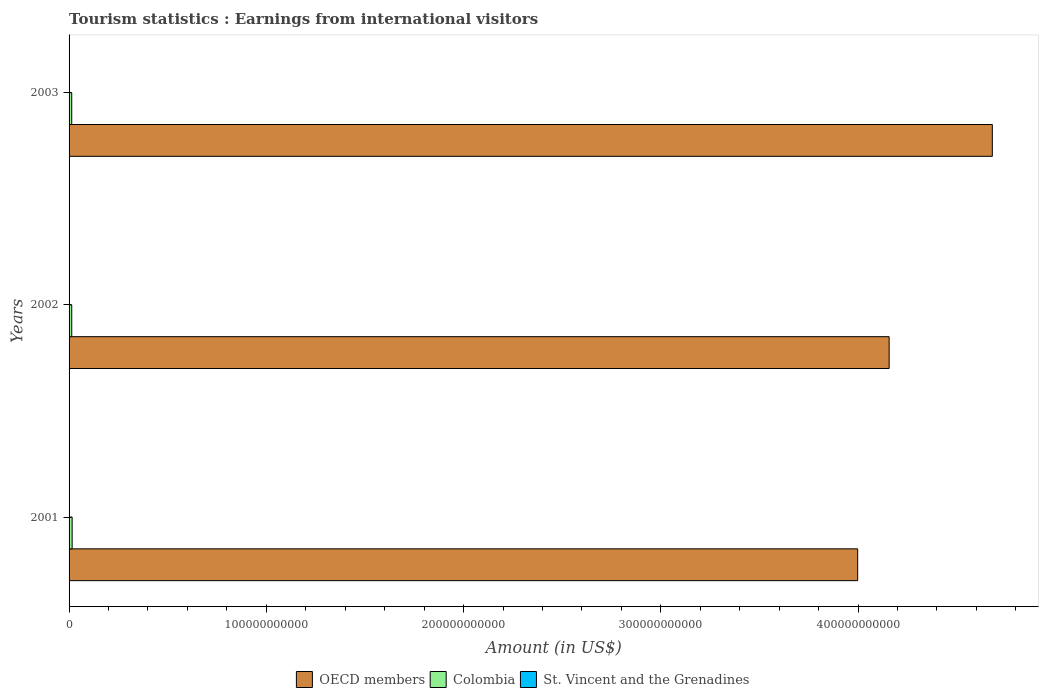How many different coloured bars are there?
Your response must be concise. 3. How many groups of bars are there?
Make the answer very short. 3. Are the number of bars on each tick of the Y-axis equal?
Your response must be concise. Yes. How many bars are there on the 1st tick from the top?
Provide a succinct answer. 3. How many bars are there on the 3rd tick from the bottom?
Make the answer very short. 3. What is the label of the 1st group of bars from the top?
Provide a succinct answer. 2003. What is the earnings from international visitors in OECD members in 2003?
Offer a terse response. 4.68e+11. Across all years, what is the maximum earnings from international visitors in OECD members?
Make the answer very short. 4.68e+11. Across all years, what is the minimum earnings from international visitors in Colombia?
Offer a very short reply. 1.35e+09. What is the total earnings from international visitors in St. Vincent and the Grenadines in the graph?
Offer a very short reply. 3.50e+07. What is the difference between the earnings from international visitors in Colombia in 2001 and that in 2002?
Ensure brevity in your answer.  2.01e+08. What is the difference between the earnings from international visitors in Colombia in 2003 and the earnings from international visitors in OECD members in 2002?
Your answer should be very brief. -4.14e+11. What is the average earnings from international visitors in St. Vincent and the Grenadines per year?
Give a very brief answer. 1.17e+07. In the year 2001, what is the difference between the earnings from international visitors in Colombia and earnings from international visitors in OECD members?
Offer a very short reply. -3.98e+11. In how many years, is the earnings from international visitors in OECD members greater than 200000000000 US$?
Make the answer very short. 3. What is the ratio of the earnings from international visitors in Colombia in 2001 to that in 2003?
Provide a short and direct response. 1.15. Is the earnings from international visitors in St. Vincent and the Grenadines in 2001 less than that in 2003?
Make the answer very short. Yes. Is the difference between the earnings from international visitors in Colombia in 2001 and 2003 greater than the difference between the earnings from international visitors in OECD members in 2001 and 2003?
Provide a succinct answer. Yes. What is the difference between the highest and the second highest earnings from international visitors in OECD members?
Make the answer very short. 5.23e+1. What is the difference between the highest and the lowest earnings from international visitors in Colombia?
Make the answer very short. 2.07e+08. In how many years, is the earnings from international visitors in Colombia greater than the average earnings from international visitors in Colombia taken over all years?
Give a very brief answer. 1. What does the 2nd bar from the top in 2003 represents?
Make the answer very short. Colombia. Is it the case that in every year, the sum of the earnings from international visitors in Colombia and earnings from international visitors in St. Vincent and the Grenadines is greater than the earnings from international visitors in OECD members?
Provide a succinct answer. No. How many years are there in the graph?
Offer a very short reply. 3. What is the difference between two consecutive major ticks on the X-axis?
Make the answer very short. 1.00e+11. Are the values on the major ticks of X-axis written in scientific E-notation?
Your answer should be compact. No. Does the graph contain any zero values?
Give a very brief answer. No. Where does the legend appear in the graph?
Your answer should be compact. Bottom center. How many legend labels are there?
Ensure brevity in your answer.  3. How are the legend labels stacked?
Offer a very short reply. Horizontal. What is the title of the graph?
Offer a terse response. Tourism statistics : Earnings from international visitors. What is the label or title of the Y-axis?
Offer a terse response. Years. What is the Amount (in US$) of OECD members in 2001?
Your answer should be compact. 4.00e+11. What is the Amount (in US$) in Colombia in 2001?
Ensure brevity in your answer.  1.56e+09. What is the Amount (in US$) in OECD members in 2002?
Provide a succinct answer. 4.16e+11. What is the Amount (in US$) in Colombia in 2002?
Your answer should be very brief. 1.36e+09. What is the Amount (in US$) of OECD members in 2003?
Make the answer very short. 4.68e+11. What is the Amount (in US$) in Colombia in 2003?
Your answer should be very brief. 1.35e+09. What is the Amount (in US$) in St. Vincent and the Grenadines in 2003?
Your response must be concise. 1.30e+07. Across all years, what is the maximum Amount (in US$) of OECD members?
Your answer should be very brief. 4.68e+11. Across all years, what is the maximum Amount (in US$) in Colombia?
Ensure brevity in your answer.  1.56e+09. Across all years, what is the maximum Amount (in US$) in St. Vincent and the Grenadines?
Give a very brief answer. 1.30e+07. Across all years, what is the minimum Amount (in US$) of OECD members?
Your answer should be compact. 4.00e+11. Across all years, what is the minimum Amount (in US$) of Colombia?
Provide a succinct answer. 1.35e+09. Across all years, what is the minimum Amount (in US$) in St. Vincent and the Grenadines?
Give a very brief answer. 1.00e+07. What is the total Amount (in US$) of OECD members in the graph?
Offer a very short reply. 1.28e+12. What is the total Amount (in US$) in Colombia in the graph?
Your answer should be compact. 4.26e+09. What is the total Amount (in US$) of St. Vincent and the Grenadines in the graph?
Ensure brevity in your answer.  3.50e+07. What is the difference between the Amount (in US$) in OECD members in 2001 and that in 2002?
Offer a terse response. -1.60e+1. What is the difference between the Amount (in US$) of Colombia in 2001 and that in 2002?
Give a very brief answer. 2.01e+08. What is the difference between the Amount (in US$) in OECD members in 2001 and that in 2003?
Your answer should be very brief. -6.83e+1. What is the difference between the Amount (in US$) in Colombia in 2001 and that in 2003?
Provide a succinct answer. 2.07e+08. What is the difference between the Amount (in US$) in St. Vincent and the Grenadines in 2001 and that in 2003?
Your response must be concise. -1.00e+06. What is the difference between the Amount (in US$) of OECD members in 2002 and that in 2003?
Provide a short and direct response. -5.23e+1. What is the difference between the Amount (in US$) of Colombia in 2002 and that in 2003?
Give a very brief answer. 6.00e+06. What is the difference between the Amount (in US$) of St. Vincent and the Grenadines in 2002 and that in 2003?
Your response must be concise. -3.00e+06. What is the difference between the Amount (in US$) of OECD members in 2001 and the Amount (in US$) of Colombia in 2002?
Ensure brevity in your answer.  3.98e+11. What is the difference between the Amount (in US$) of OECD members in 2001 and the Amount (in US$) of St. Vincent and the Grenadines in 2002?
Your answer should be very brief. 4.00e+11. What is the difference between the Amount (in US$) of Colombia in 2001 and the Amount (in US$) of St. Vincent and the Grenadines in 2002?
Offer a terse response. 1.55e+09. What is the difference between the Amount (in US$) of OECD members in 2001 and the Amount (in US$) of Colombia in 2003?
Provide a short and direct response. 3.98e+11. What is the difference between the Amount (in US$) of OECD members in 2001 and the Amount (in US$) of St. Vincent and the Grenadines in 2003?
Offer a very short reply. 4.00e+11. What is the difference between the Amount (in US$) of Colombia in 2001 and the Amount (in US$) of St. Vincent and the Grenadines in 2003?
Ensure brevity in your answer.  1.54e+09. What is the difference between the Amount (in US$) of OECD members in 2002 and the Amount (in US$) of Colombia in 2003?
Your answer should be very brief. 4.14e+11. What is the difference between the Amount (in US$) in OECD members in 2002 and the Amount (in US$) in St. Vincent and the Grenadines in 2003?
Offer a very short reply. 4.16e+11. What is the difference between the Amount (in US$) in Colombia in 2002 and the Amount (in US$) in St. Vincent and the Grenadines in 2003?
Your response must be concise. 1.34e+09. What is the average Amount (in US$) in OECD members per year?
Provide a succinct answer. 4.28e+11. What is the average Amount (in US$) of Colombia per year?
Your response must be concise. 1.42e+09. What is the average Amount (in US$) of St. Vincent and the Grenadines per year?
Keep it short and to the point. 1.17e+07. In the year 2001, what is the difference between the Amount (in US$) of OECD members and Amount (in US$) of Colombia?
Your answer should be very brief. 3.98e+11. In the year 2001, what is the difference between the Amount (in US$) in OECD members and Amount (in US$) in St. Vincent and the Grenadines?
Your answer should be compact. 4.00e+11. In the year 2001, what is the difference between the Amount (in US$) in Colombia and Amount (in US$) in St. Vincent and the Grenadines?
Keep it short and to the point. 1.54e+09. In the year 2002, what is the difference between the Amount (in US$) of OECD members and Amount (in US$) of Colombia?
Your response must be concise. 4.14e+11. In the year 2002, what is the difference between the Amount (in US$) in OECD members and Amount (in US$) in St. Vincent and the Grenadines?
Provide a succinct answer. 4.16e+11. In the year 2002, what is the difference between the Amount (in US$) of Colombia and Amount (in US$) of St. Vincent and the Grenadines?
Keep it short and to the point. 1.34e+09. In the year 2003, what is the difference between the Amount (in US$) in OECD members and Amount (in US$) in Colombia?
Provide a short and direct response. 4.67e+11. In the year 2003, what is the difference between the Amount (in US$) in OECD members and Amount (in US$) in St. Vincent and the Grenadines?
Give a very brief answer. 4.68e+11. In the year 2003, what is the difference between the Amount (in US$) of Colombia and Amount (in US$) of St. Vincent and the Grenadines?
Your answer should be very brief. 1.34e+09. What is the ratio of the Amount (in US$) of OECD members in 2001 to that in 2002?
Ensure brevity in your answer.  0.96. What is the ratio of the Amount (in US$) of Colombia in 2001 to that in 2002?
Ensure brevity in your answer.  1.15. What is the ratio of the Amount (in US$) of OECD members in 2001 to that in 2003?
Provide a succinct answer. 0.85. What is the ratio of the Amount (in US$) in Colombia in 2001 to that in 2003?
Your response must be concise. 1.15. What is the ratio of the Amount (in US$) of OECD members in 2002 to that in 2003?
Provide a short and direct response. 0.89. What is the ratio of the Amount (in US$) of St. Vincent and the Grenadines in 2002 to that in 2003?
Keep it short and to the point. 0.77. What is the difference between the highest and the second highest Amount (in US$) of OECD members?
Offer a very short reply. 5.23e+1. What is the difference between the highest and the second highest Amount (in US$) of Colombia?
Give a very brief answer. 2.01e+08. What is the difference between the highest and the second highest Amount (in US$) of St. Vincent and the Grenadines?
Your response must be concise. 1.00e+06. What is the difference between the highest and the lowest Amount (in US$) in OECD members?
Give a very brief answer. 6.83e+1. What is the difference between the highest and the lowest Amount (in US$) of Colombia?
Make the answer very short. 2.07e+08. What is the difference between the highest and the lowest Amount (in US$) of St. Vincent and the Grenadines?
Your answer should be compact. 3.00e+06. 